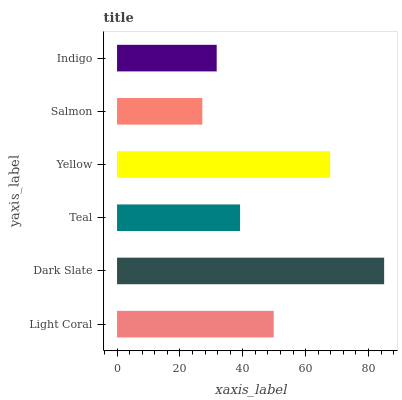Is Salmon the minimum?
Answer yes or no. Yes. Is Dark Slate the maximum?
Answer yes or no. Yes. Is Teal the minimum?
Answer yes or no. No. Is Teal the maximum?
Answer yes or no. No. Is Dark Slate greater than Teal?
Answer yes or no. Yes. Is Teal less than Dark Slate?
Answer yes or no. Yes. Is Teal greater than Dark Slate?
Answer yes or no. No. Is Dark Slate less than Teal?
Answer yes or no. No. Is Light Coral the high median?
Answer yes or no. Yes. Is Teal the low median?
Answer yes or no. Yes. Is Indigo the high median?
Answer yes or no. No. Is Salmon the low median?
Answer yes or no. No. 